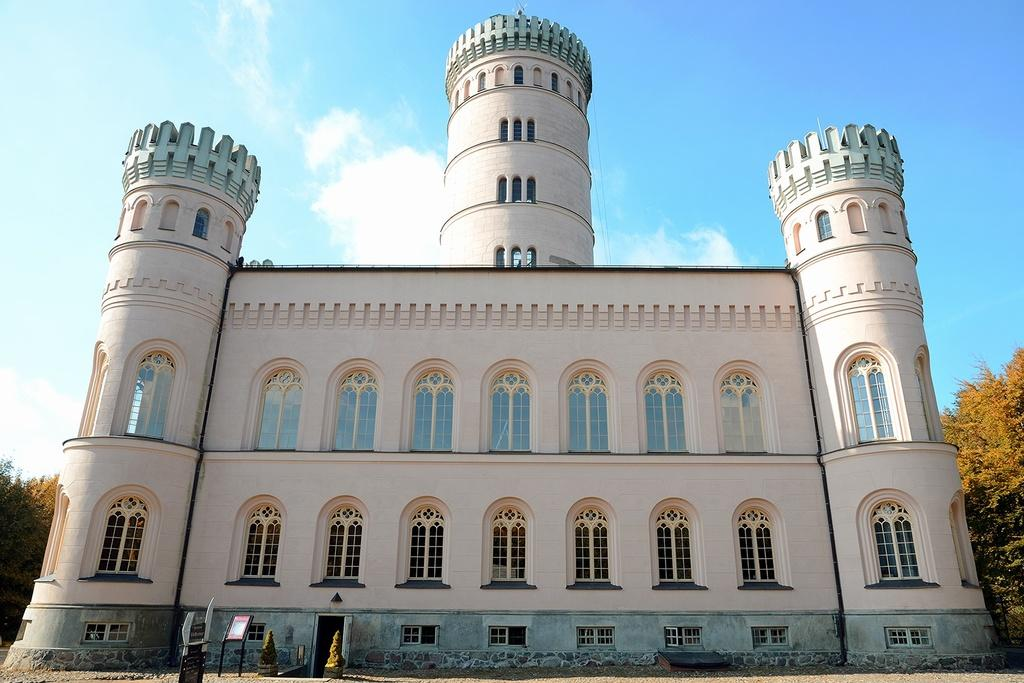What is the main structure in the picture? There is a building in the picture. What can be seen on the left side of the picture? There are trees on the left side of the picture. What can be seen on the right side of the picture? There are trees on the right side of the picture. What is visible at the top of the picture? The sky is clear and visible at the top of the picture. What is the price of the land in the picture? There is no information about the price of the land in the picture, as it only shows a building, trees, and the sky. 